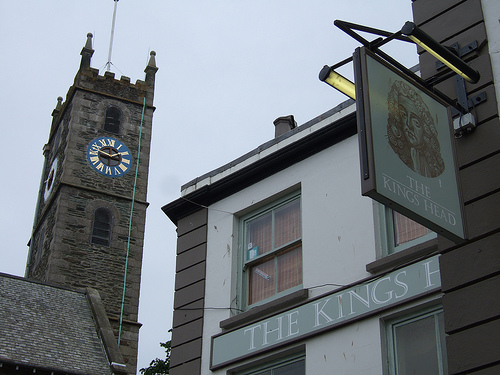What can you tell about the historical significance of the tower with the clock? The tower with the clock likely holds historical significance to the community, serving not just as a timekeeping fixture but also as a landmark within the town. Its design suggests it may have been built in the Victorian era, a common period for such elaborate public clocks in Britain. 